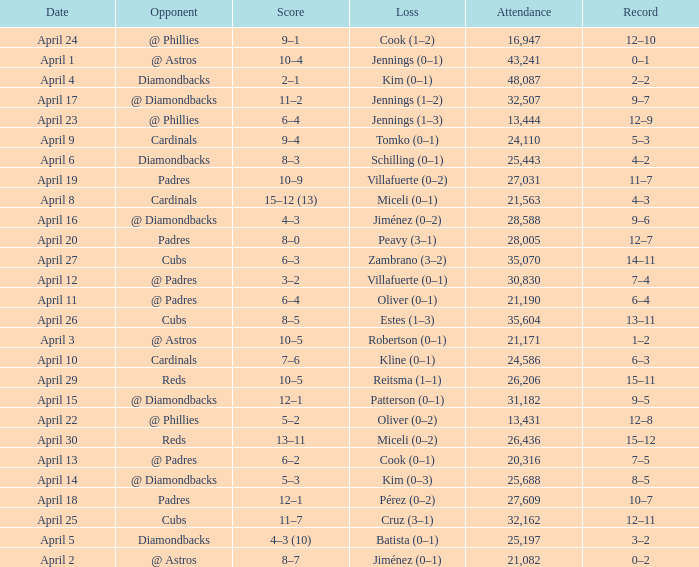Who is the opponent on april 16? @ Diamondbacks. 